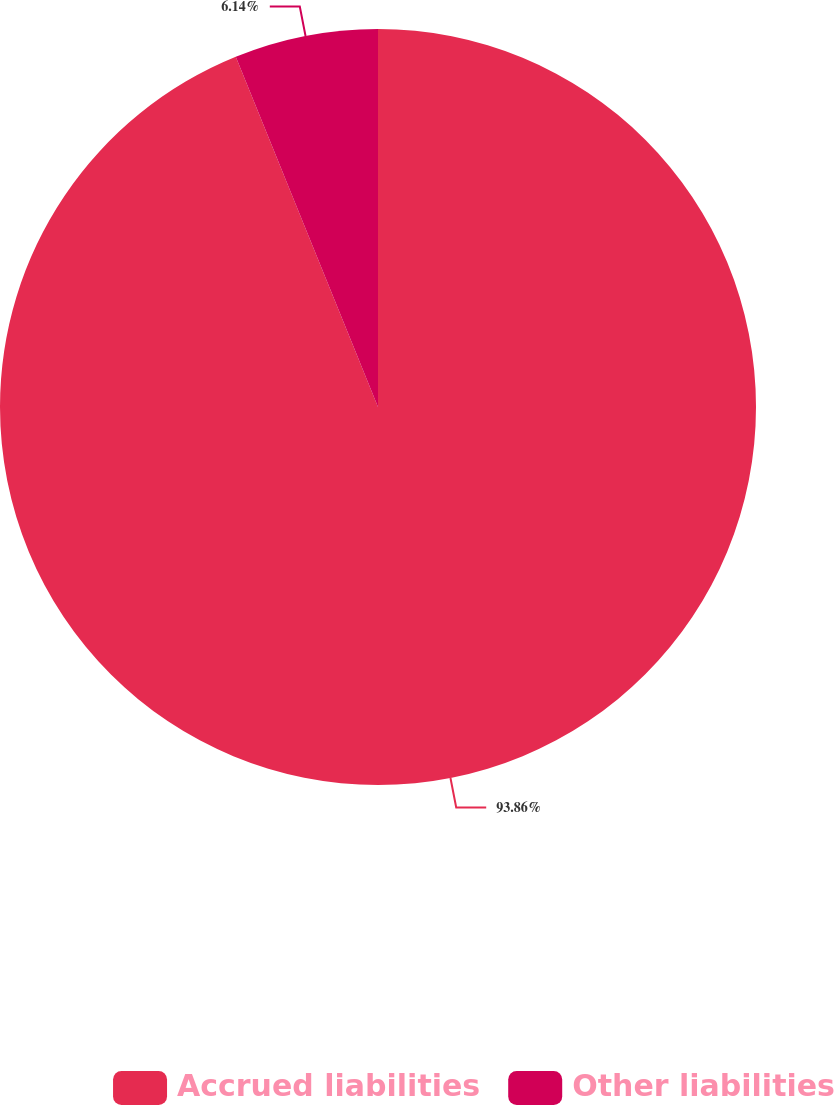Convert chart to OTSL. <chart><loc_0><loc_0><loc_500><loc_500><pie_chart><fcel>Accrued liabilities<fcel>Other liabilities<nl><fcel>93.86%<fcel>6.14%<nl></chart> 